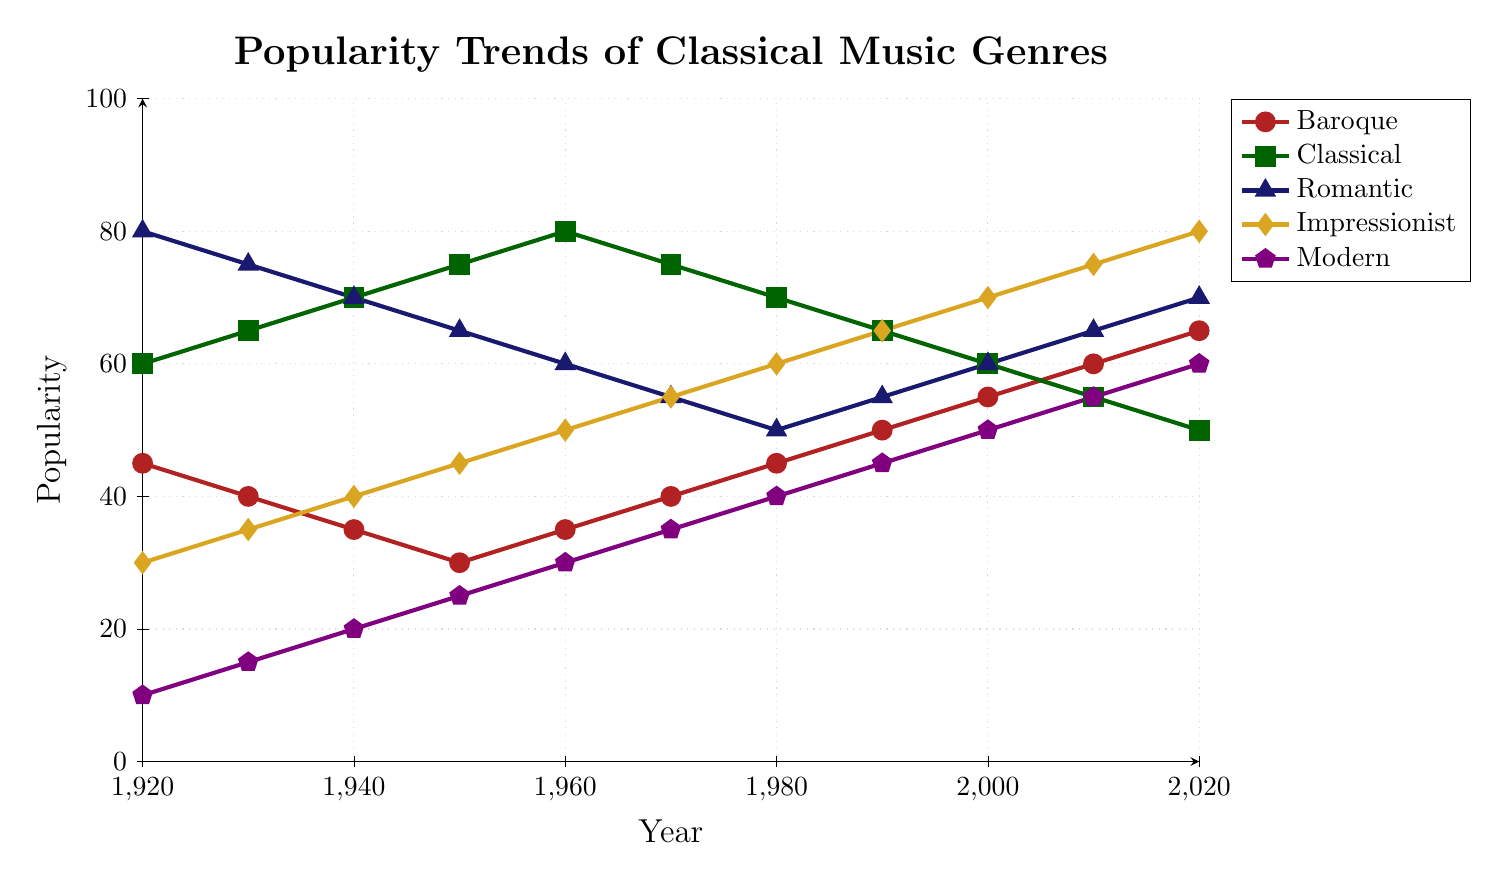what year did the Impressionist genre surpass the Baroque genre in popularity? To find the year the Impressionist genre surpassed the Baroque genre in popularity, look for the point where the yellow line of the Impressionist genre moves above the red line of the Baroque genre. This occurs between 1970 and 1980.
Answer: 1980 which genre had the highest popularity in the year 2020? To determine which genre had the highest popularity in 2020, check the ending points of the lines. The line with the highest point in 2020 belongs to the yellow line, which represents the Impressionist genre.
Answer: Impressionist in which decades did the Romantic genre have a decreasing trend in popularity? To identify the decades when the Romantic genre had decreasing trends, look for downward slopes in the blue line representing Romantic music. The popularity decreased from 1920 to 1960 and from 1960 to 1980.
Answer: 1920s, 1930s, 1940s, 1950s, 1960s, 1970s what is the average popularity of the Baroque genre from 1920 to 2020? To compute the average popularity of the Baroque genre, add up the values provided for each decade and divide by the number of decades: (45 + 40 + 35 + 30 + 35 + 40 + 45 + 50 + 55 + 60 + 65) / 11 = 500 / 11.
Answer: 45.45 which genre shows consistent growth in popularity throughout the century? To determine which genre shows consistent growth, find the line that continuously moves upwards without any downward slope. The yellow line representing the Impressionist genre shows a continuous upward trend.
Answer: Impressionist how does the popularity of the Classical genre in 1920 compare to its popularity in 2020? To compare the popularity of the Classical genre in 1920 and 2020, look at the green line for these years. The value in 1920 is 60, and in 2020 it is 50. Therefore, the popularity decreased by 10 points.
Answer: Decreased by 10 points how many genres have peak popularity higher than 70 at any point in the past century? To determine how many genres have a peak popularity higher than 70, look for the highest point in each line. The genres meeting this criterion are Classical (peak 80), Romantic (peak 80), and Impressionist (peak 80).
Answer: 3 what is the difference in popularity between the Baroque and Modern genres in 2020? To find the difference in popularity between the Baroque and Modern genres in 2020, subtract the popularity of the Modern genre from the Baroque genre in 2020: 65 - 60 = 5.
Answer: 5 which genre experienced the most significant drop in popularity within a single decade? To determine the genre with the most significant drop in popularity within a single decade, look for the steepest downward slope in any line. The Classical genre has the most significant drop from 1980 to 1990 (70 to 65).
Answer: Classical in what year were the Baroque and Classical genres equally popular? To identify the year when the Baroque and Classical genres were equally popular, find the intersecting point of the red and green lines. The two lines intersect between 2010 and 2020.
Answer: 2020 